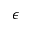Convert formula to latex. <formula><loc_0><loc_0><loc_500><loc_500>\epsilon</formula> 